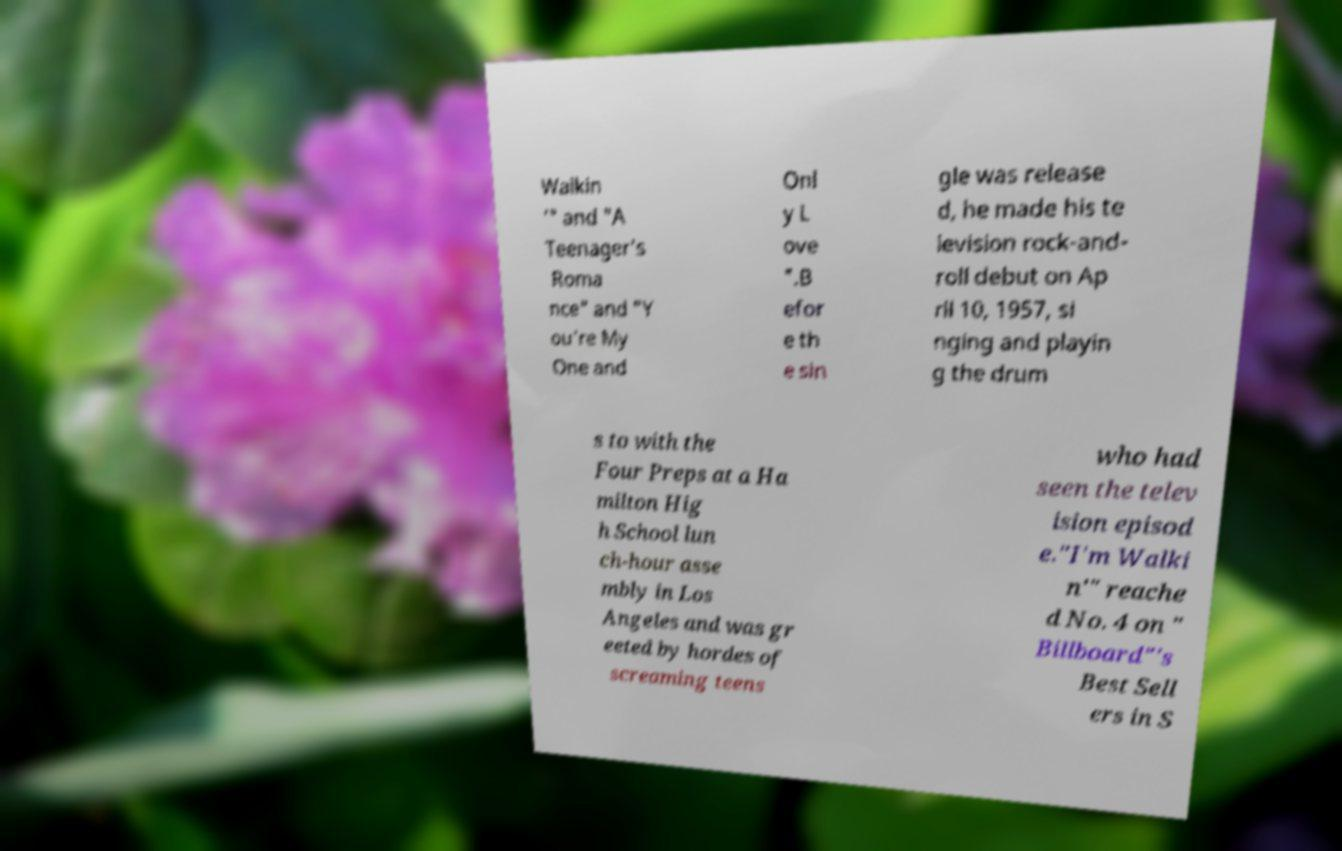Could you extract and type out the text from this image? Walkin '" and "A Teenager's Roma nce" and "Y ou're My One and Onl y L ove ".B efor e th e sin gle was release d, he made his te levision rock-and- roll debut on Ap ril 10, 1957, si nging and playin g the drum s to with the Four Preps at a Ha milton Hig h School lun ch-hour asse mbly in Los Angeles and was gr eeted by hordes of screaming teens who had seen the telev ision episod e."I'm Walki n'" reache d No. 4 on " Billboard"'s Best Sell ers in S 